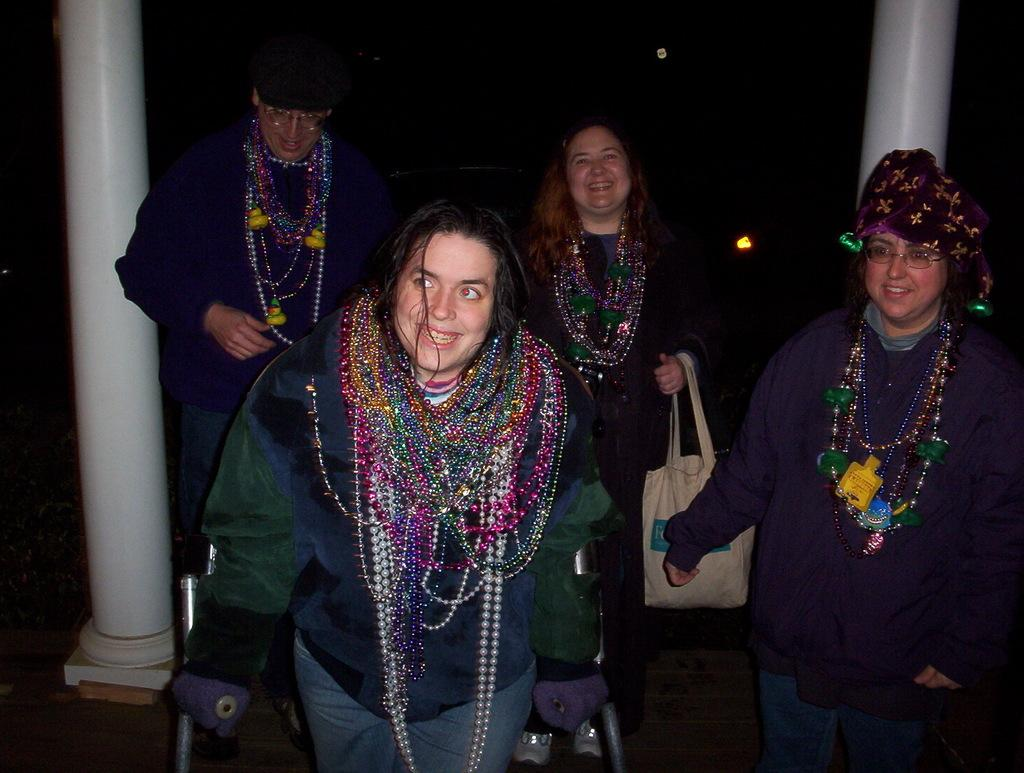How many people are in the image? There are four persons in the image. What are the persons doing in the image? The persons are standing and smiling. What can be seen in the background of the image? There are two pillars in the background, and the background is in black color. What type of badge is the beast wearing in the image? There is no beast or badge present in the image. What kind of cloth is draped over the pillars in the image? There is no cloth draped over the pillars in the image; only the pillars and the black background are visible. 